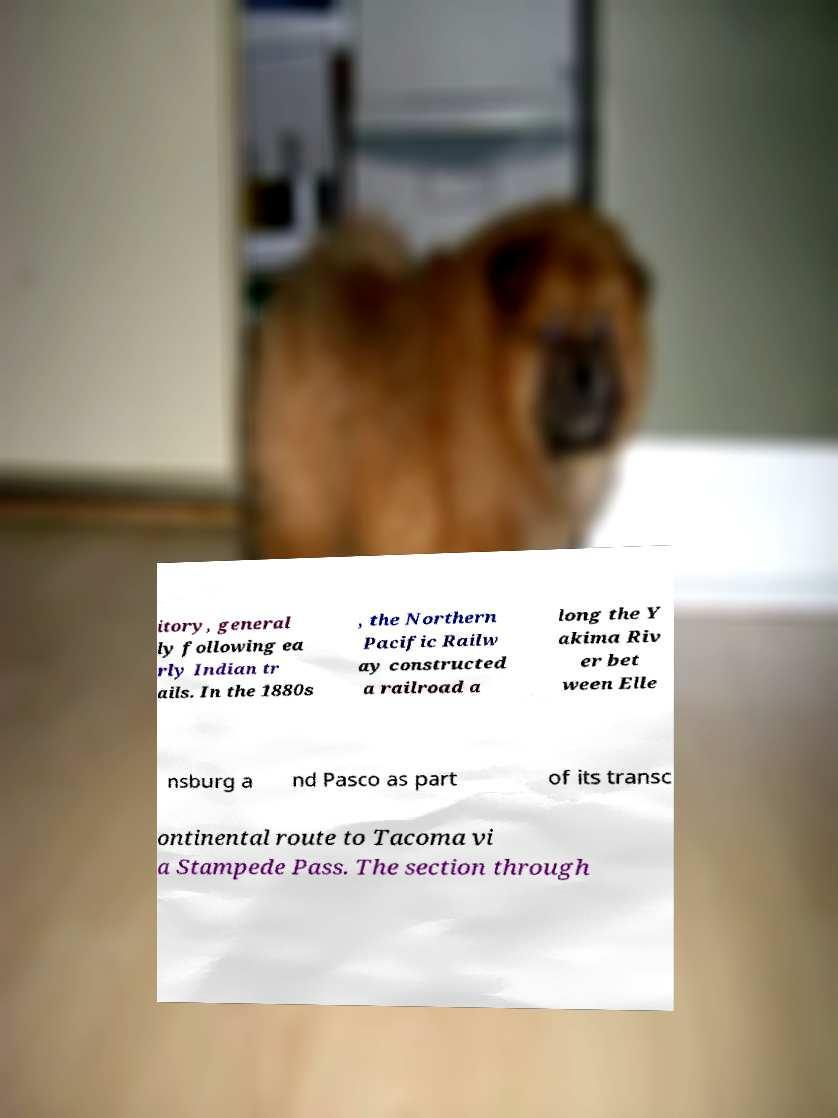I need the written content from this picture converted into text. Can you do that? itory, general ly following ea rly Indian tr ails. In the 1880s , the Northern Pacific Railw ay constructed a railroad a long the Y akima Riv er bet ween Elle nsburg a nd Pasco as part of its transc ontinental route to Tacoma vi a Stampede Pass. The section through 